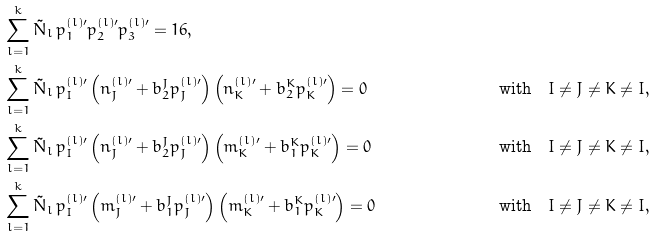Convert formula to latex. <formula><loc_0><loc_0><loc_500><loc_500>& \sum _ { l = 1 } ^ { k } { \tilde { N } _ { l } } \, { p ^ { ( l ) \prime } _ { 1 } } { p ^ { ( l ) \prime } _ { 2 } } { p ^ { ( l ) \prime } _ { 3 } } = 1 6 , & \\ & \sum _ { l = 1 } ^ { k } { \tilde { N } _ { l } } \, { p ^ { ( l ) \prime } _ { I } } \left ( n ^ { ( l ) \prime } _ { J } + b _ { 2 } ^ { J } p ^ { ( l ) \prime } _ { J } \right ) \left ( n ^ { ( l ) \prime } _ { K } + b _ { 2 } ^ { K } p ^ { ( l ) \prime } _ { K } \right ) = 0 & & \text {with\quad } I \neq J \neq K \neq I , \\ & \sum _ { l = 1 } ^ { k } { \tilde { N } _ { l } } \, { p ^ { ( l ) \prime } _ { I } } \left ( n ^ { ( l ) \prime } _ { J } + b _ { 2 } ^ { J } p ^ { ( l ) \prime } _ { J } \right ) \left ( m ^ { ( l ) \prime } _ { K } + b _ { 1 } ^ { K } p ^ { ( l ) \prime } _ { K } \right ) = 0 & & \text {with\quad } I \neq J \neq K \neq I , \\ & \sum _ { l = 1 } ^ { k } { \tilde { N } _ { l } } \, { p ^ { ( l ) \prime } _ { I } } \left ( m ^ { ( l ) \prime } _ { J } + b _ { 1 } ^ { J } p ^ { ( l ) \prime } _ { J } \right ) \left ( m ^ { ( l ) \prime } _ { K } + b _ { 1 } ^ { K } p ^ { ( l ) \prime } _ { K } \right ) = 0 & & \text {with\quad } I \neq J \neq K \neq I ,</formula> 